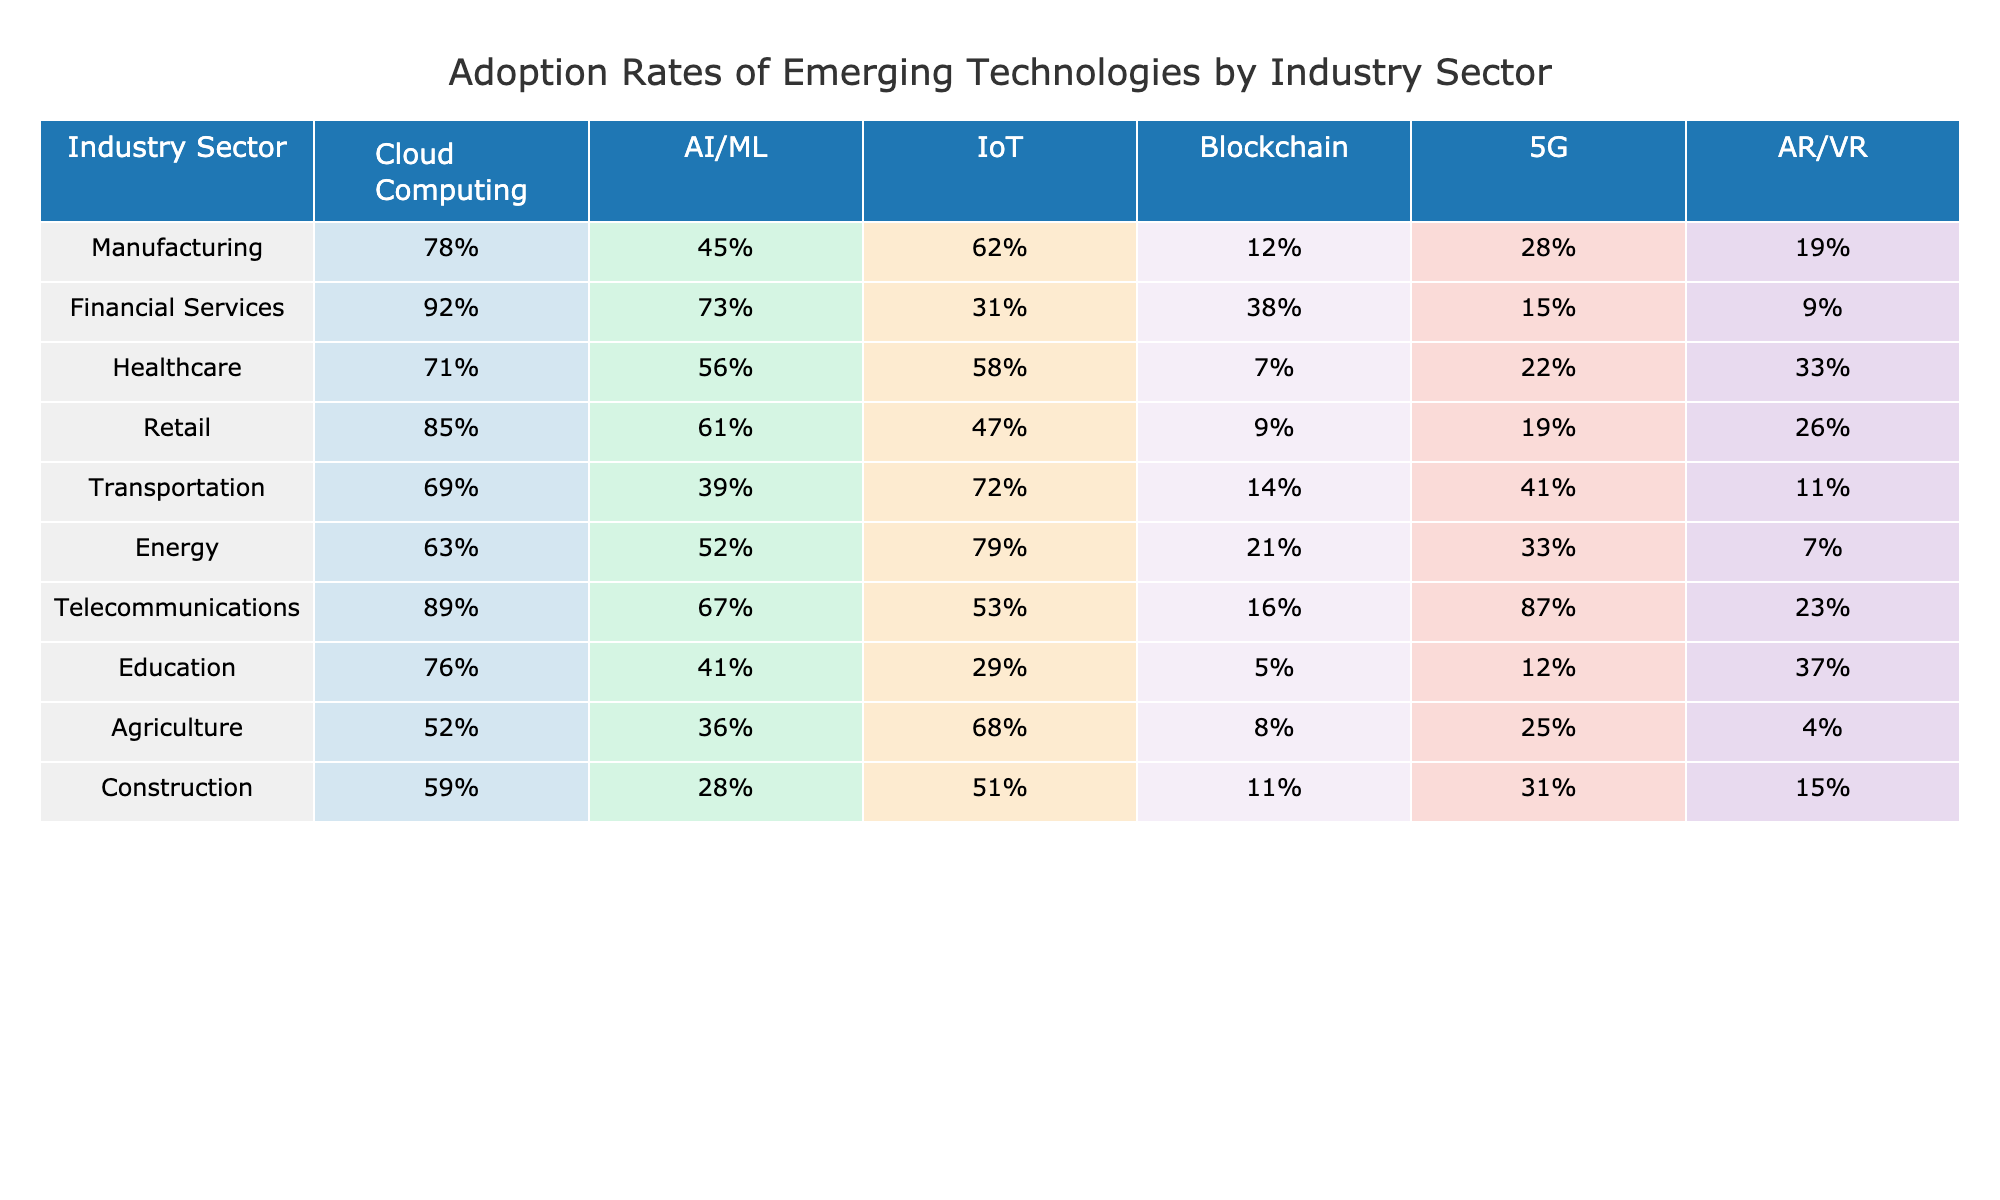What industry sector has the highest adoption rate of cloud computing? By looking at the cloud computing column, the Financial Services sector has the highest value at 92%.
Answer: Financial Services What is the lowest adoption rate for AI/ML technology among the industries? The lowest adoption rate for AI/ML can be seen in the Construction sector, which is 28%.
Answer: 28% Which sector has the highest adoption rate for IoT technologies? The highest adoption rate for IoT is in the Energy sector at 79%.
Answer: Energy Is the adoption rate of Blockchain technology higher in the Telecommunications sector compared to the Transportation sector? The Telecommunications sector has a Blockchain adoption rate of 16%, while the Transportation sector has a rate of 14%. Hence, yes, Telecommunications is higher.
Answer: Yes What is the average adoption rate of AR/VR across all sectors? To calculate the average, sum the AR/VR adoption rates: (19 + 9 + 33 + 26 + 11 + 7 + 23 + 37 + 4 + 15) = 284, and divide by the number of sectors (10) gives 28.4%.
Answer: 28.4% Which industry sectors have an adoption rate of 20% or lower for Blockchain? The sectors with 20% or lower are Manufacturing (12%), Healthcare (7%), and Agriculture (8%).
Answer: Manufacturing, Healthcare, Agriculture If you compare the adoption rates of 5G in Healthcare and Education, which one is greater? In the Healthcare sector, the adoption rate for 5G is 22%, while in the Education sector, it's 12%. Therefore, 5G adoption is greater in Healthcare.
Answer: Healthcare What is the difference in the adoption rates of AI/ML between the Telecommunications and Agriculture sectors? The Telecommunications sector has an AI/ML rate of 67%, while Agriculture has 36%. The difference is 67% - 36% = 31%.
Answer: 31% Which two sectors have the closest adoption rates for IoT technology? By examining the IoT column, the Retail sector at 47% and the Agriculture sector at 68% show the closest rate. The difference is only 21%.
Answer: Retail and Agriculture What percentage of sectors have a Blockchain adoption rate of less than 15%? The sectors with rates below 15% are Manufacturing (12%) and Healthcare (7%), which is 2 out of 10 sectors, equating to 20%.
Answer: 20% 